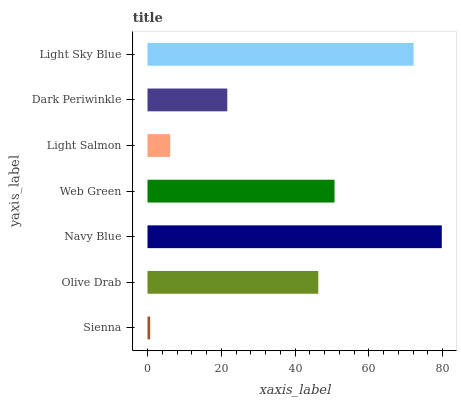Is Sienna the minimum?
Answer yes or no. Yes. Is Navy Blue the maximum?
Answer yes or no. Yes. Is Olive Drab the minimum?
Answer yes or no. No. Is Olive Drab the maximum?
Answer yes or no. No. Is Olive Drab greater than Sienna?
Answer yes or no. Yes. Is Sienna less than Olive Drab?
Answer yes or no. Yes. Is Sienna greater than Olive Drab?
Answer yes or no. No. Is Olive Drab less than Sienna?
Answer yes or no. No. Is Olive Drab the high median?
Answer yes or no. Yes. Is Olive Drab the low median?
Answer yes or no. Yes. Is Web Green the high median?
Answer yes or no. No. Is Web Green the low median?
Answer yes or no. No. 